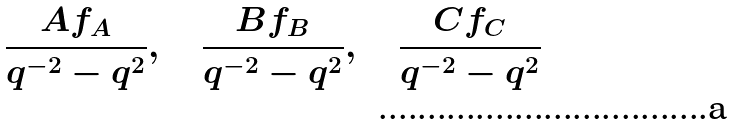Convert formula to latex. <formula><loc_0><loc_0><loc_500><loc_500>\frac { A f _ { A } } { q ^ { - 2 } - q ^ { 2 } } , \quad \frac { B f _ { B } } { q ^ { - 2 } - q ^ { 2 } } , \quad \frac { C f _ { C } } { q ^ { - 2 } - q ^ { 2 } }</formula> 